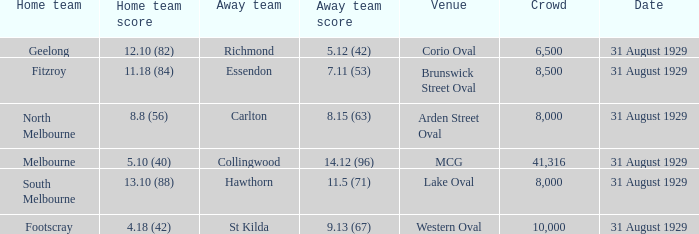What is the score of the away team when the crowd was larger than 8,000? 9.13 (67), 7.11 (53), 14.12 (96). 